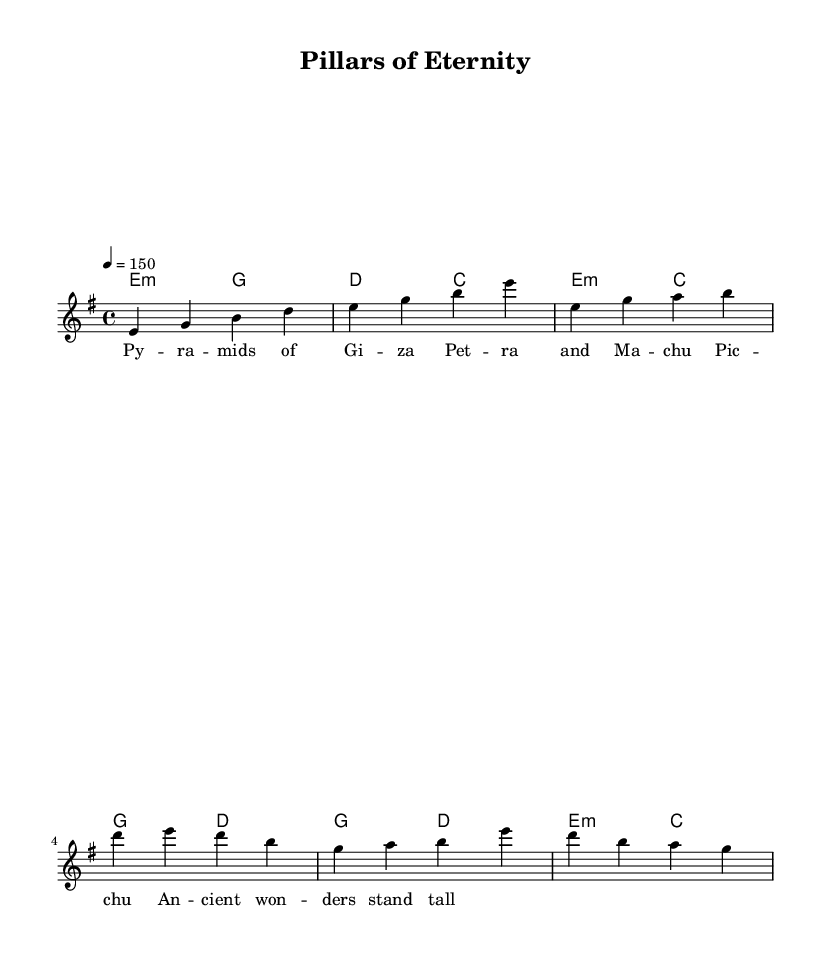What is the key signature of this music? The key signature is E minor, which has one sharp (F#) and typically involves a range of notes suitable for a darker, more intense sound often used in metal music.
Answer: E minor What is the time signature of this music? The time signature is 4/4, indicating four beats per measure, which is a common time signature in many genres including metal for its driving rhythm.
Answer: 4/4 What is the tempo marking for this piece? The tempo marking is 150 beats per minute, which tells musicians to play at a brisk and energetic pace, typical for power metal, enhancing its epic quality.
Answer: 150 What two ancient architectural wonders are mentioned in the lyrics? The lyrics explicitly mention "Pyramids of Giza" and "Machu Picchu," highlighting these iconic structures as symbols of ancient civilizations in the context of the song.
Answer: Pyramids of Giza, Machu Picchu How many measures are in the chorus section? The chorus section consists of 2 measures based on the provided melody, which reflects a structured and thematic approach typical in metal music.
Answer: 2 What is the primary chord used in the intro? The primary chord used in the intro is E minor, establishing a dark and powerful foundation that is common in metal music compositions.
Answer: E minor Which musical mode is used for the harmonies? The harmonies utilize the chord mode, specifically C major for the... providing rich harmonic support that complements the lead melody and enhances the overall epic atmosphere.
Answer: Chord mode 